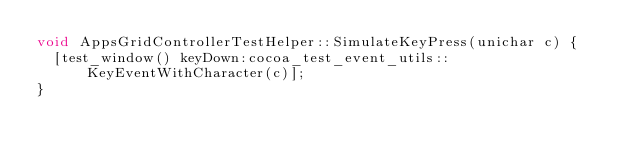<code> <loc_0><loc_0><loc_500><loc_500><_ObjectiveC_>void AppsGridControllerTestHelper::SimulateKeyPress(unichar c) {
  [test_window() keyDown:cocoa_test_event_utils::KeyEventWithCharacter(c)];
}
</code> 